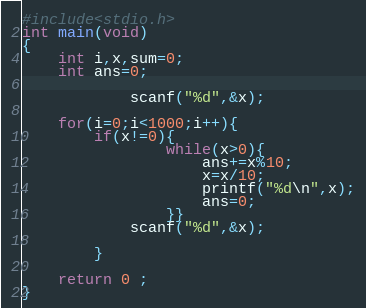<code> <loc_0><loc_0><loc_500><loc_500><_C_>#include<stdio.h>
int main(void)
{
	int i,x,sum=0;
	int ans=0;
	
			scanf("%d",&x);

	for(i=0;i<1000;i++){
		if(x!=0){
				while(x>0){
					ans+=x%10;
			        x=x/10;
					printf("%d\n",x);
					ans=0;
				}}
			scanf("%d",&x);

		}
	
	return 0 ;
}</code> 